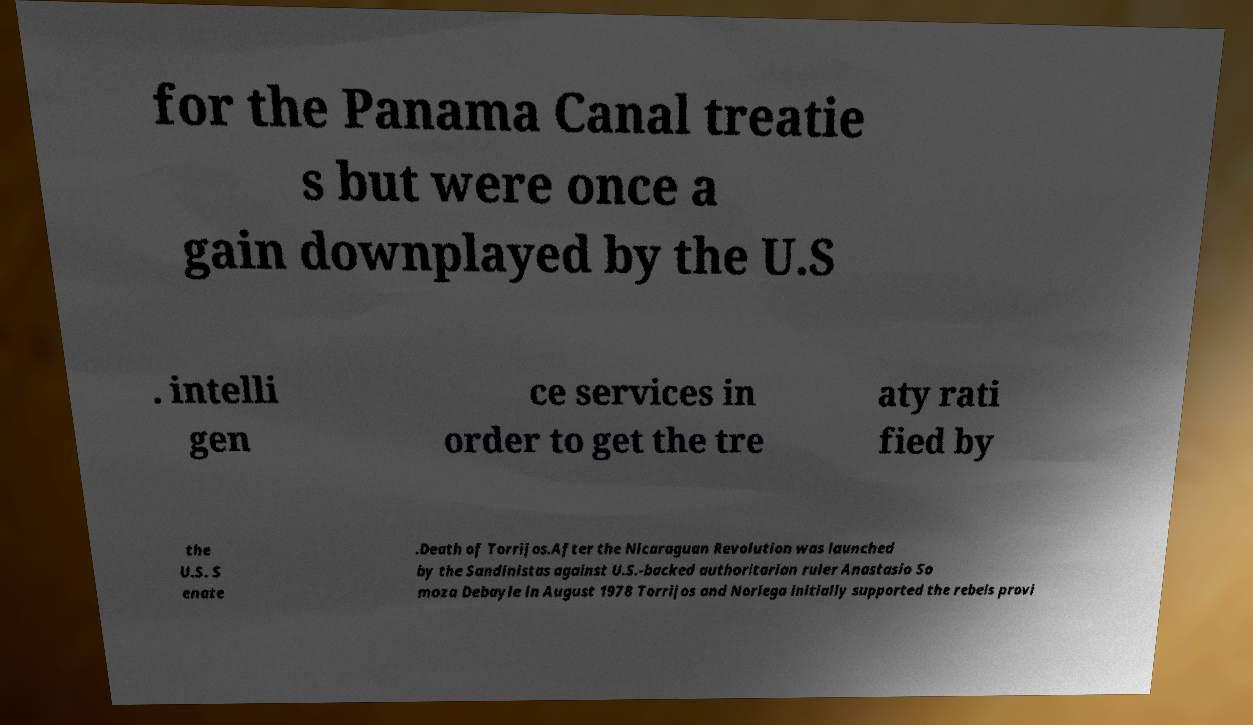Can you read and provide the text displayed in the image?This photo seems to have some interesting text. Can you extract and type it out for me? for the Panama Canal treatie s but were once a gain downplayed by the U.S . intelli gen ce services in order to get the tre aty rati fied by the U.S. S enate .Death of Torrijos.After the Nicaraguan Revolution was launched by the Sandinistas against U.S.-backed authoritarian ruler Anastasio So moza Debayle in August 1978 Torrijos and Noriega initially supported the rebels provi 